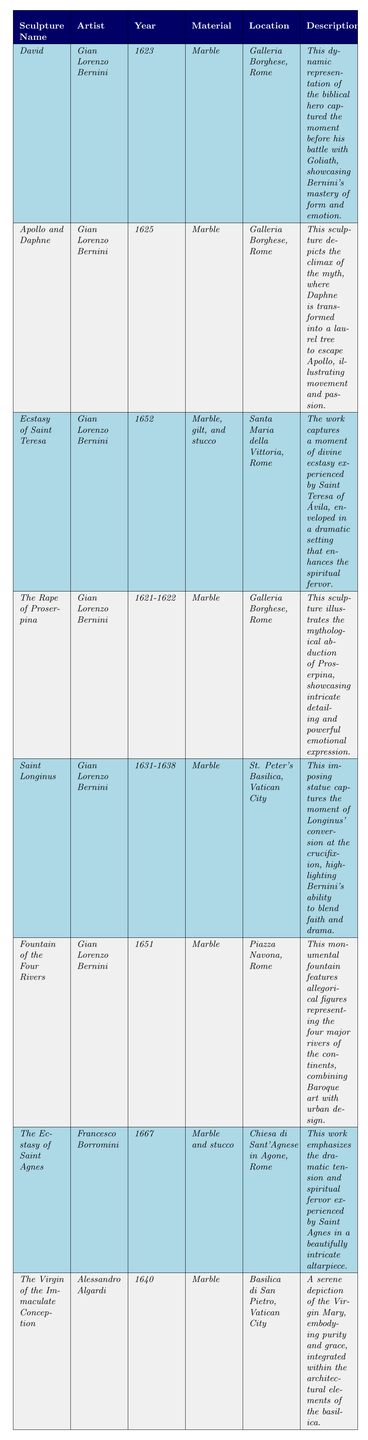What is the year of completion for "*Apollo and Daphne*"? The table lists the year of completion for the sculpture "*Apollo and Daphne*" as "*1625*".
Answer: 1625 Who is the artist of "*The Ecstasy of Saint Teresa*"? According to the table, "*The Ecstasy of Saint Teresa*" was created by the artist "*Gian Lorenzo Bernini*".
Answer: Gian Lorenzo Bernini Which material was used for "*The Virgin of the Immaculate Conception*"? The table specifies that "*The Virgin of the Immaculate Conception*" is made of "*Marble*".
Answer: Marble How many sculptures were completed before the year 1640? By checking the years of completion in the table, we find that three sculptures were completed before 1640: "*David*" (1623), "*Apollo and Daphne*" (1625), and "*The Rape of Proserpina*" (1621-1622).
Answer: 3 Which sculpture has a description emphasizing spiritual fervor? The sculpture "*Ecstasy of Saint Teresa*" has a description emphasizing spiritual fervor, stating it captures a moment of divine ecstasy experienced by Saint Teresa.
Answer: Ecstasy of Saint Teresa Is "*Fountain of the Four Rivers*" located in Galleria Borghese? The table shows that "*Fountain of the Four Rivers*" is located in "*Piazza Navona, Rome*", not in Galleria Borghese.
Answer: No What are the names of the two sculptures created by *Gian Lorenzo Bernini* that depict mythical themes? The table lists "*Apollo and Daphne*" and "*The Rape of Proserpina*" as the two sculptures created by *Gian Lorenzo Bernini* that depict mythical themes.
Answer: Apollo and Daphne, The Rape of Proserpina Which artist has the most sculptures listed in the table and how many are there? The table shows that *Gian Lorenzo Bernini* created five sculptures: "*David*", "*Apollo and Daphne*", "*Ecstasy of Saint Teresa*", "*The Rape of Proserpina*", and "*Saint Longinus*".
Answer: Gian Lorenzo Bernini, 5 What is the average year of completion for the sculptures listed? Calculating the average year: (1623 + 1625 + 1652 + 1621.5 + 1634.5 + 1651 + 1667 + 1640) / 8 = 1640.125. The average year rounds to 1640 when considering whole years.
Answer: 1640 How many sculptures are located in St. Peter's Basilica? The table indicates that there is one sculpture located in St. Peter's Basilica: "*Saint Longinus*".
Answer: 1 Did any sculptures use materials other than marble? The table indicates that "*Ecstasy of Saint Teresa*" and "*The Ecstasy of Saint Agnes*" used additional materials (stucco and gilt), confirming that there are sculptures made with materials other than just marble.
Answer: Yes 